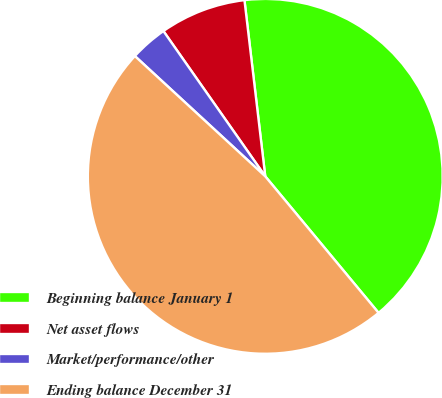<chart> <loc_0><loc_0><loc_500><loc_500><pie_chart><fcel>Beginning balance January 1<fcel>Net asset flows<fcel>Market/performance/other<fcel>Ending balance December 31<nl><fcel>40.84%<fcel>7.86%<fcel>3.41%<fcel>47.88%<nl></chart> 